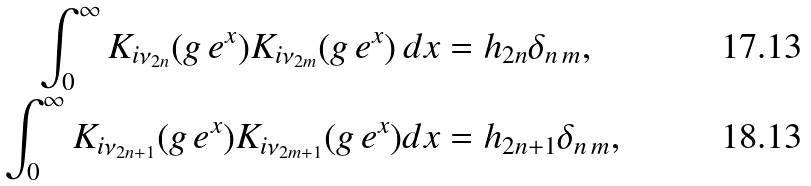Convert formula to latex. <formula><loc_0><loc_0><loc_500><loc_500>\int _ { 0 } ^ { \infty } K _ { i \nu _ { 2 n } } ( g \, e ^ { x } ) K _ { i \nu _ { 2 m } } ( g \, e ^ { x } ) \, d x & = h _ { 2 n } \delta _ { n \, m } , \\ \int _ { 0 } ^ { \infty } K _ { i \nu _ { 2 n + 1 } } ( g \, e ^ { x } ) K _ { i \nu _ { 2 m + 1 } } ( g \, e ^ { x } ) d x & = h _ { 2 n + 1 } \delta _ { n \, m } ,</formula> 